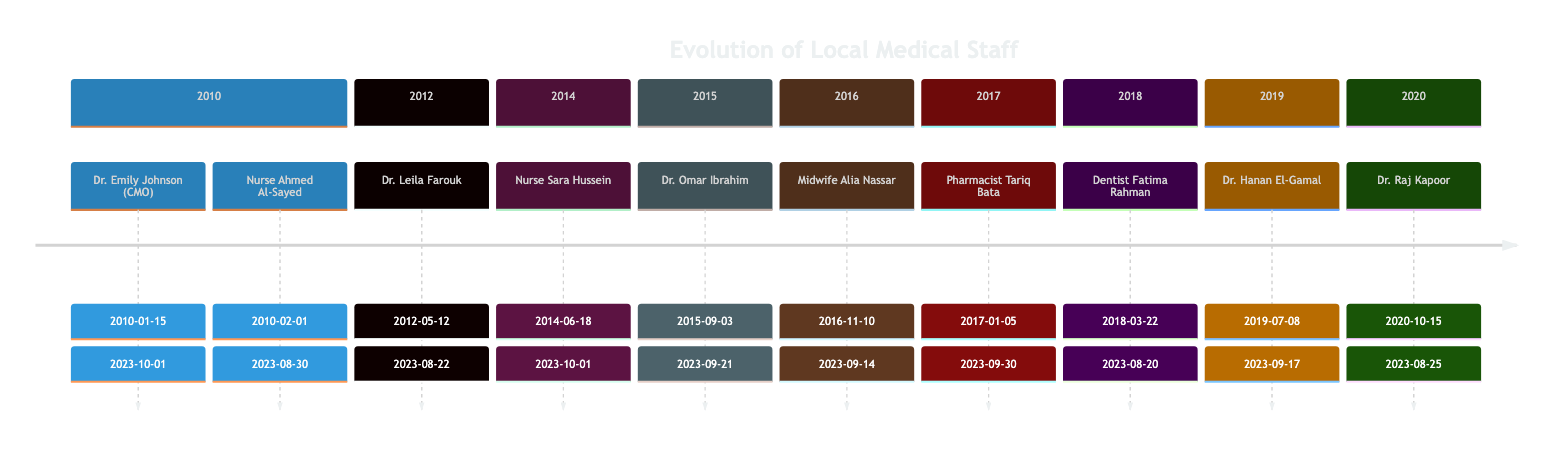What is the duration of Dr. Emily Johnson's tenure? Dr. Emily Johnson started on January 15, 2010, and ended on October 1, 2023. To find the duration, calculate the difference between the start and end dates. This results in approximately 13 years and 9 months.
Answer: 13 years 9 months Who was the first medical staff member at the clinic? The diagram indicates that Dr. Emily Johnson started as the Chief Medical Officer on January 15, 2010. As her start date is the earliest among all staff, she is the first member.
Answer: Dr. Emily Johnson How many staff members joined in 2016? The diagram shows one staff member, Midwife Alia Nassar, who started on November 10, 2016. There are no other members listed for that year.
Answer: 1 Which role was filled by Nurse Ahmed Al-Sayed? The diagram lists Nurse Ahmed Al-Sayed as a Senior Nurse, with his start date on February 1, 2010, and end date on August 30, 2023. This specific role is directly stated.
Answer: Senior Nurse Between which years did Dr. Hanan El-Gamal serve? Dr. Hanan El-Gamal started on July 8, 2019, and ended on September 17, 2023. The years of service can be established as starting in 2019 and ending in 2023.
Answer: 2019 - 2023 Which medical staff specialized in pediatrics? The diagram specifies that Dr. Leila Farouk, who started on May 12, 2012, held the role of Pediatric Specialist. This information is explicitly provided in her details.
Answer: Dr. Leila Farouk What role was created in 2018? The diagram indicates that in 2018, Dentist Fatima Rahman joined as a Dentist on March 22, 2018. Thus, the role specifically created in that year is a Dentist.
Answer: Dentist Which staff member is responsible for medication management? The diagram clearly states that Pharmacist Tariq Bata, starting on January 5, 2017, is responsible for managing medical supplies and medications. This is explicitly noted in his information.
Answer: Pharmacist Tariq Bata What is the total number of medical staff listed in the diagram? To find the total number, count the individual staff entries listed in the diagram. There are ten unique members in total.
Answer: 10 